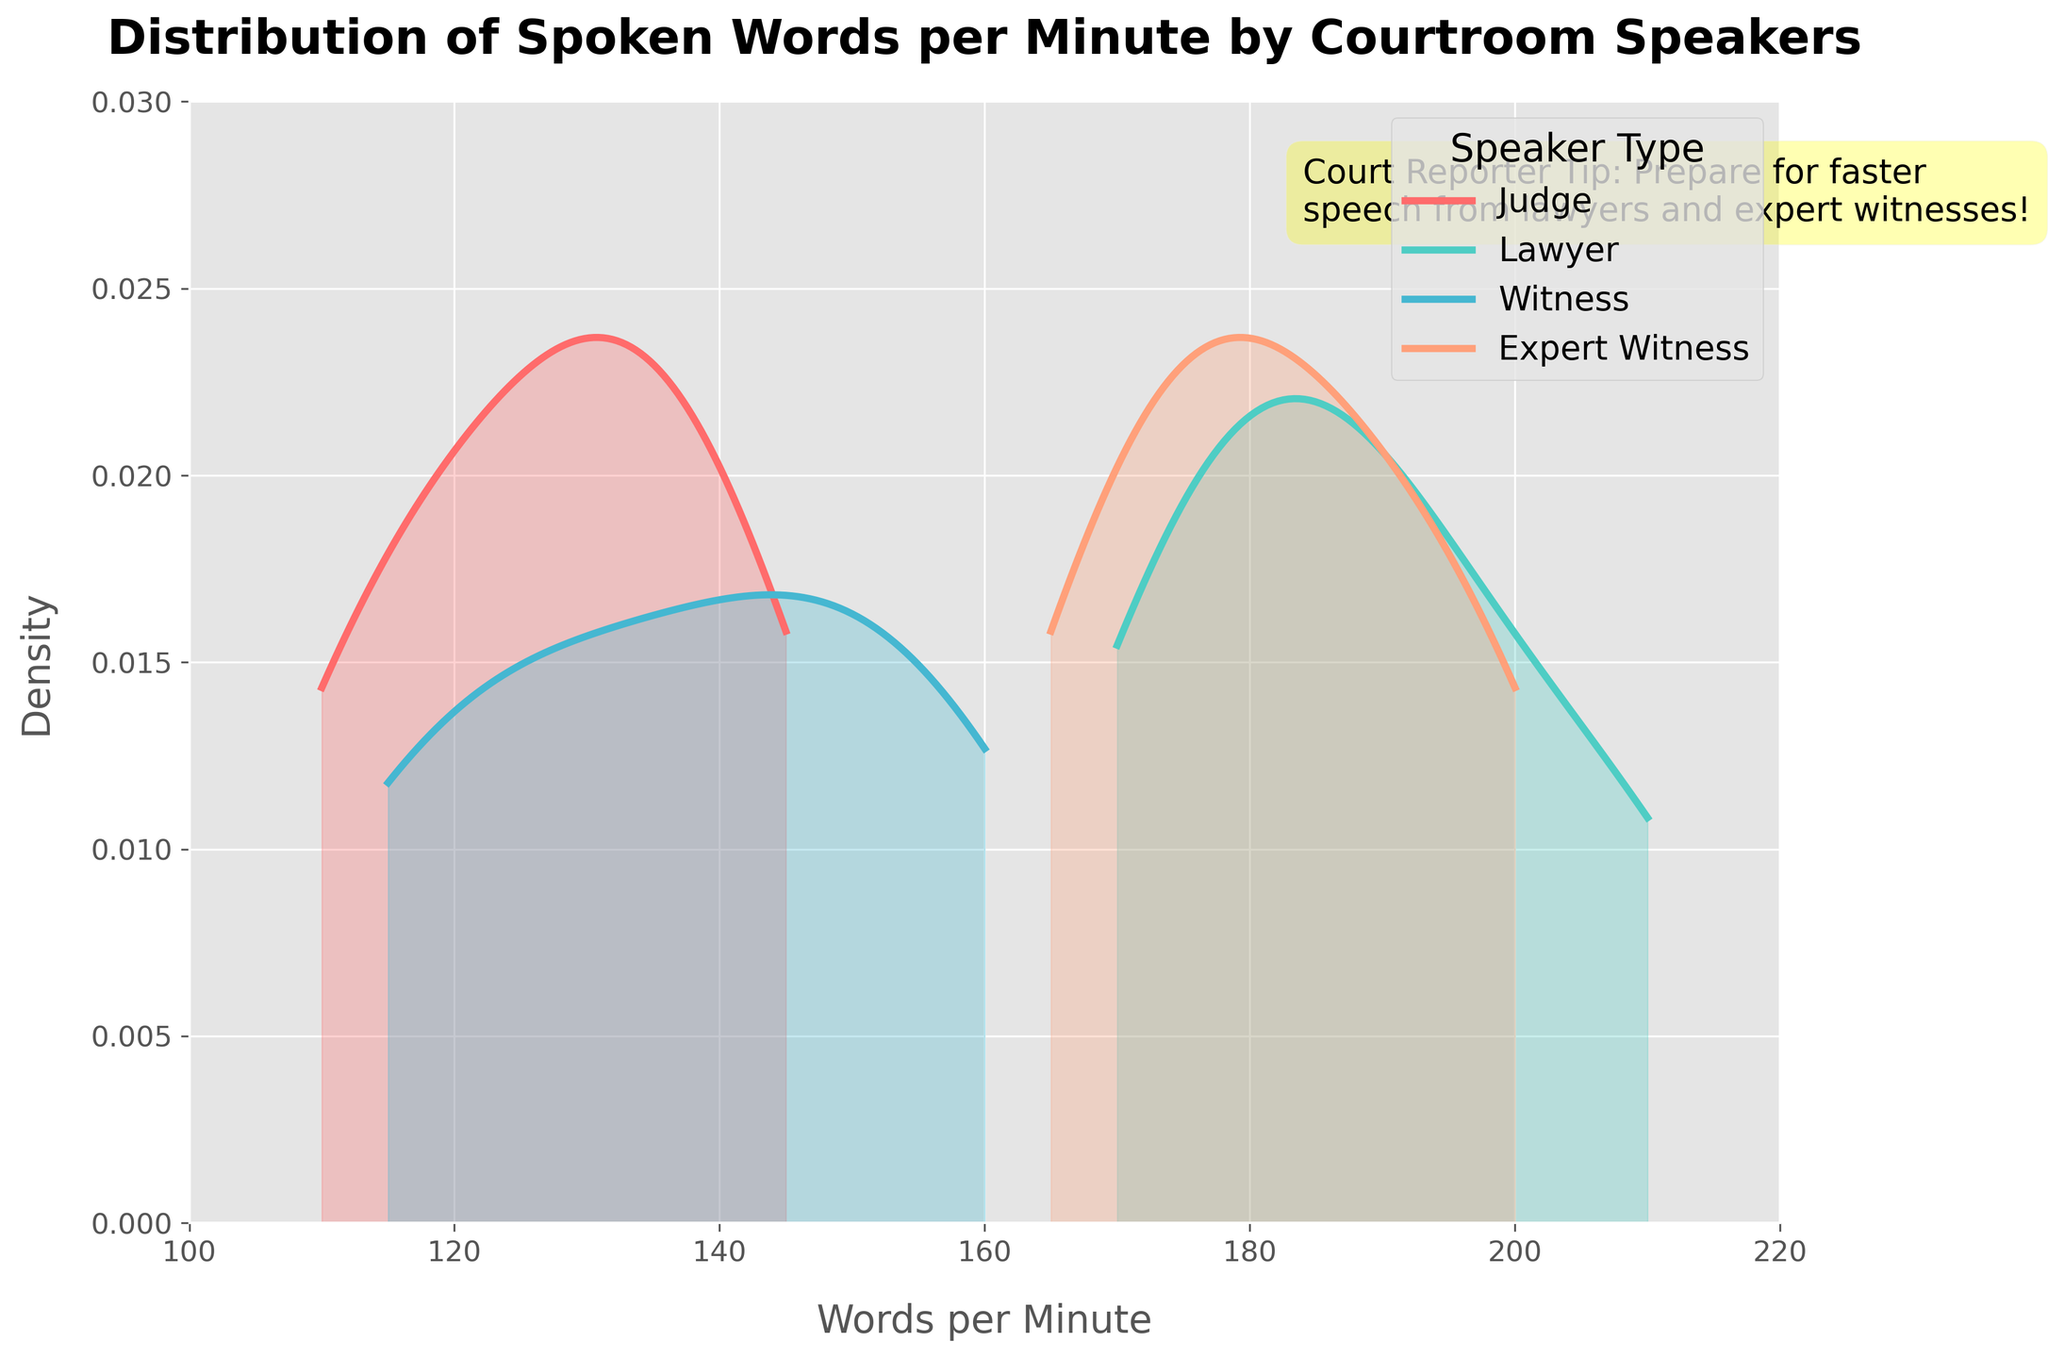What is the title of the plot? The title is the text at the top of the plot, indicating what the plot represents.
Answer: Distribution of Spoken Words per Minute by Courtroom Speakers Which speaker type has the highest peak density? By observing the y-axis and the curves, the speaker type with the highest peak density will have the highest point on the plot.
Answer: Lawyer What is the color used to represent the 'Witness' speaker type? Identify the curve and corresponding fill area linked with the 'Witness' category from the legend and observe its color.
Answer: Cyan What is the approximate range of words per minute for expert witnesses? Look at the x-axis range where the 'Expert Witness' density curve starts and ends.
Answer: 165 to 200 words per minute Which speaker type appears to speak fastest on average? The speaker type with the highest average will have the density curve centered furthest to the right on the x-axis.
Answer: Lawyer How does the distribution shape differ between Judges and Lawyers? Compare the curves for 'Judge' and 'Lawyer'. Observe width, height, and placement on the x-axis.
Answer: Lawyer's curve is narrower and shifted right Which speaker type would a court reporter need to prepare for the least variance in speaking speed? Look for the speaker with the narrowest density curve indicating less spread or variance in words per minute.
Answer: Lawyer Compare the speaking ranges of Judges and Witnesses. Which is broader? Observe the x-axis spans for 'Judge' and 'Witness'. The speaker type with a wider span has a broader range.
Answer: Judge What court reporter tip is annotated on the plot? Locate the text annotation in the plot area and read the provided message.
Answer: Prepare for faster speech from lawyers and expert witnesses 